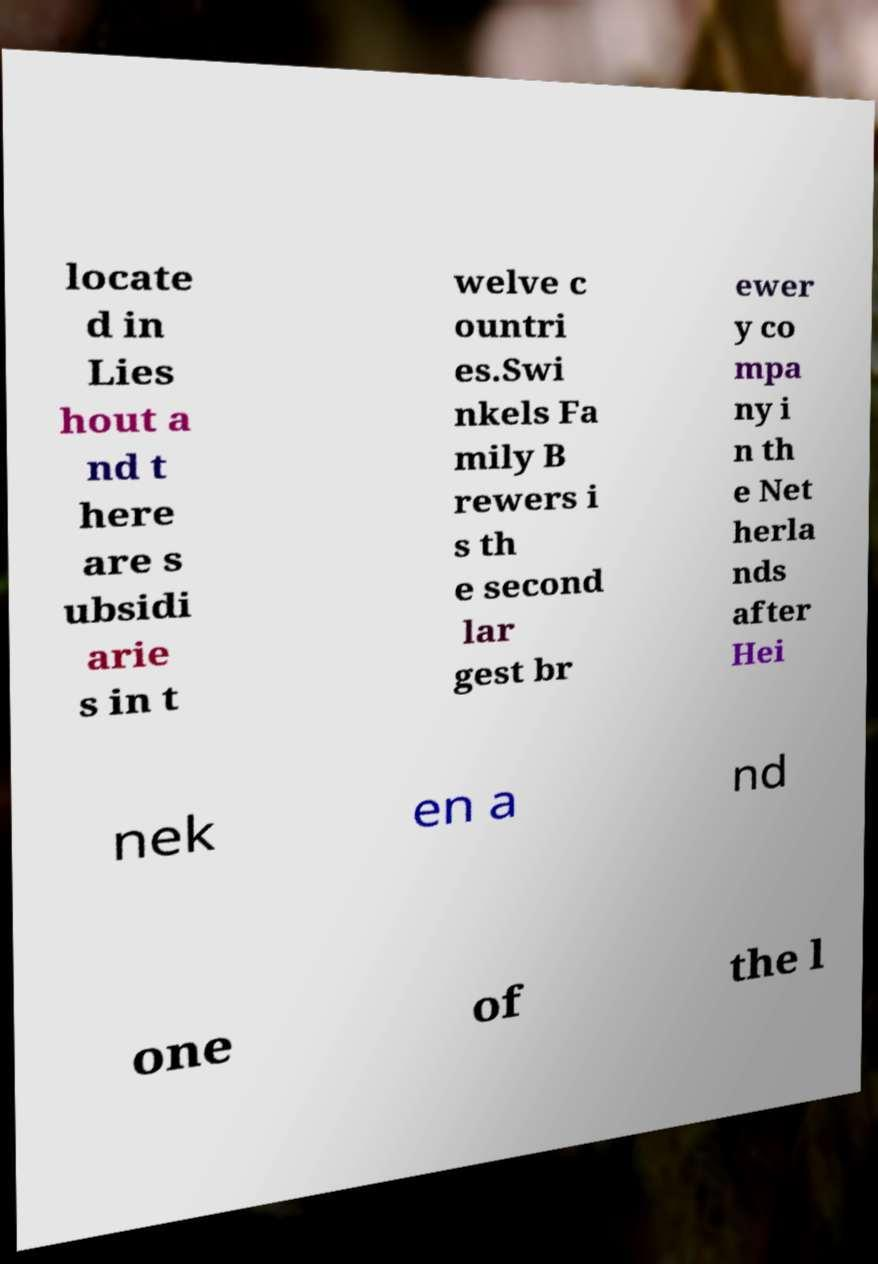Please identify and transcribe the text found in this image. locate d in Lies hout a nd t here are s ubsidi arie s in t welve c ountri es.Swi nkels Fa mily B rewers i s th e second lar gest br ewer y co mpa ny i n th e Net herla nds after Hei nek en a nd one of the l 